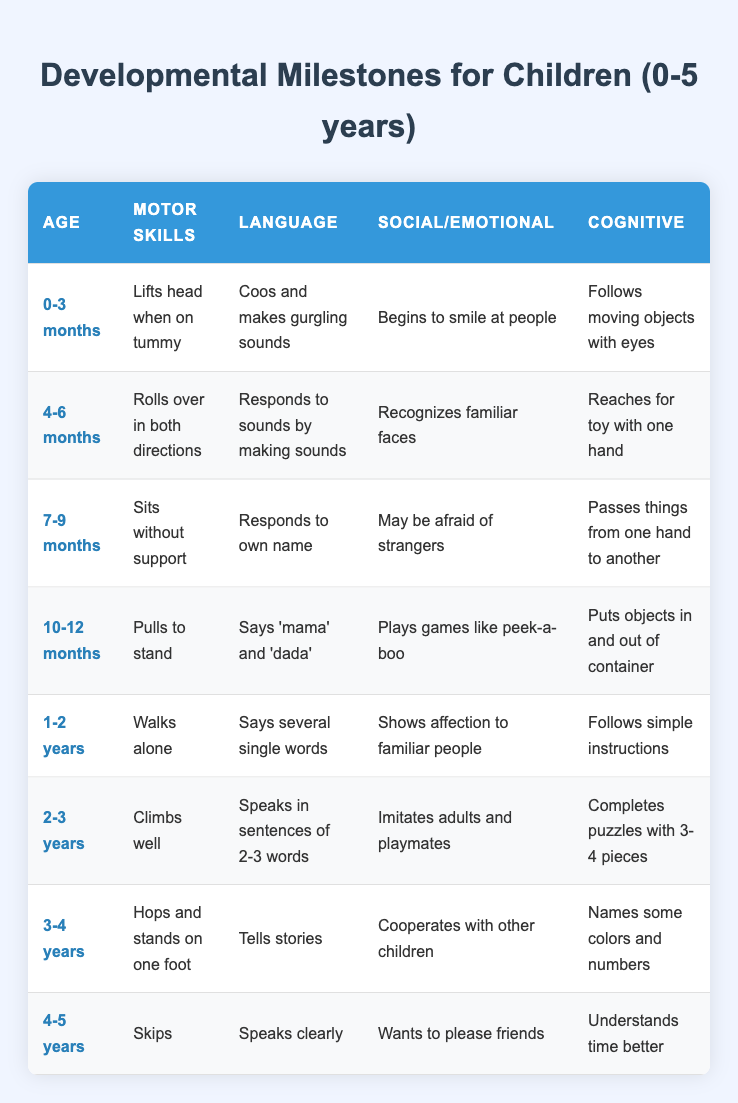What motor skill should a child demonstrate at 10-12 months? The table states that at 10-12 months, a child's motor skill milestone is "Pulls to stand."
Answer: Pulls to stand At what age does a child begin to cooperate with other children? According to the table, a child begins to cooperate with other children at 3-4 years old.
Answer: 3-4 years True or False: A child who is 4-5 years old should be able to climb well. The table shows that the skill "Climbs well" is listed under the age category 2-3 years, indicating that it is not a milestone for 4-5 years old.
Answer: False What cognitive skill is associated with children aged 1-2 years? The cognitive skill for 1-2 years old listed in the table is "Follows simple instructions."
Answer: Follows simple instructions How many different language milestones are noted for children between the ages of 0-3 months and 4-6 months? For 0-3 months, the language milestone is "Coos and makes gurgling sounds," and for 4-6 months, it is "Responds to sounds by making sounds." Therefore, there are 2 language milestones.
Answer: 2 What is the average age range for the listed milestones that involve social/emotional skills? The age ranges for social/emotional skills are: 0-3 months, 4-6 months, 7-9 months, 10-12 months, 1-2 years, 2-3 years, 3-4 years, and 4-5 years. The midpoints of these ranges can be calculated. The average of these midpoint ages (1.5, 5, 8, 11, 18, 30, 42, 54 months) is approximately 9.75 months, or about 10 months.
Answer: About 10 months At what age does a child typically begin to show affection to familiar people? The table states that a child shows affection to familiar people at the age of 1-2 years.
Answer: 1-2 years If a child can sit without support, what could you deduce about their age? Sitting without support is a milestone listed for the age category of 7-9 months according to the table, so it can be deduced that the child is around that age.
Answer: 7-9 months 